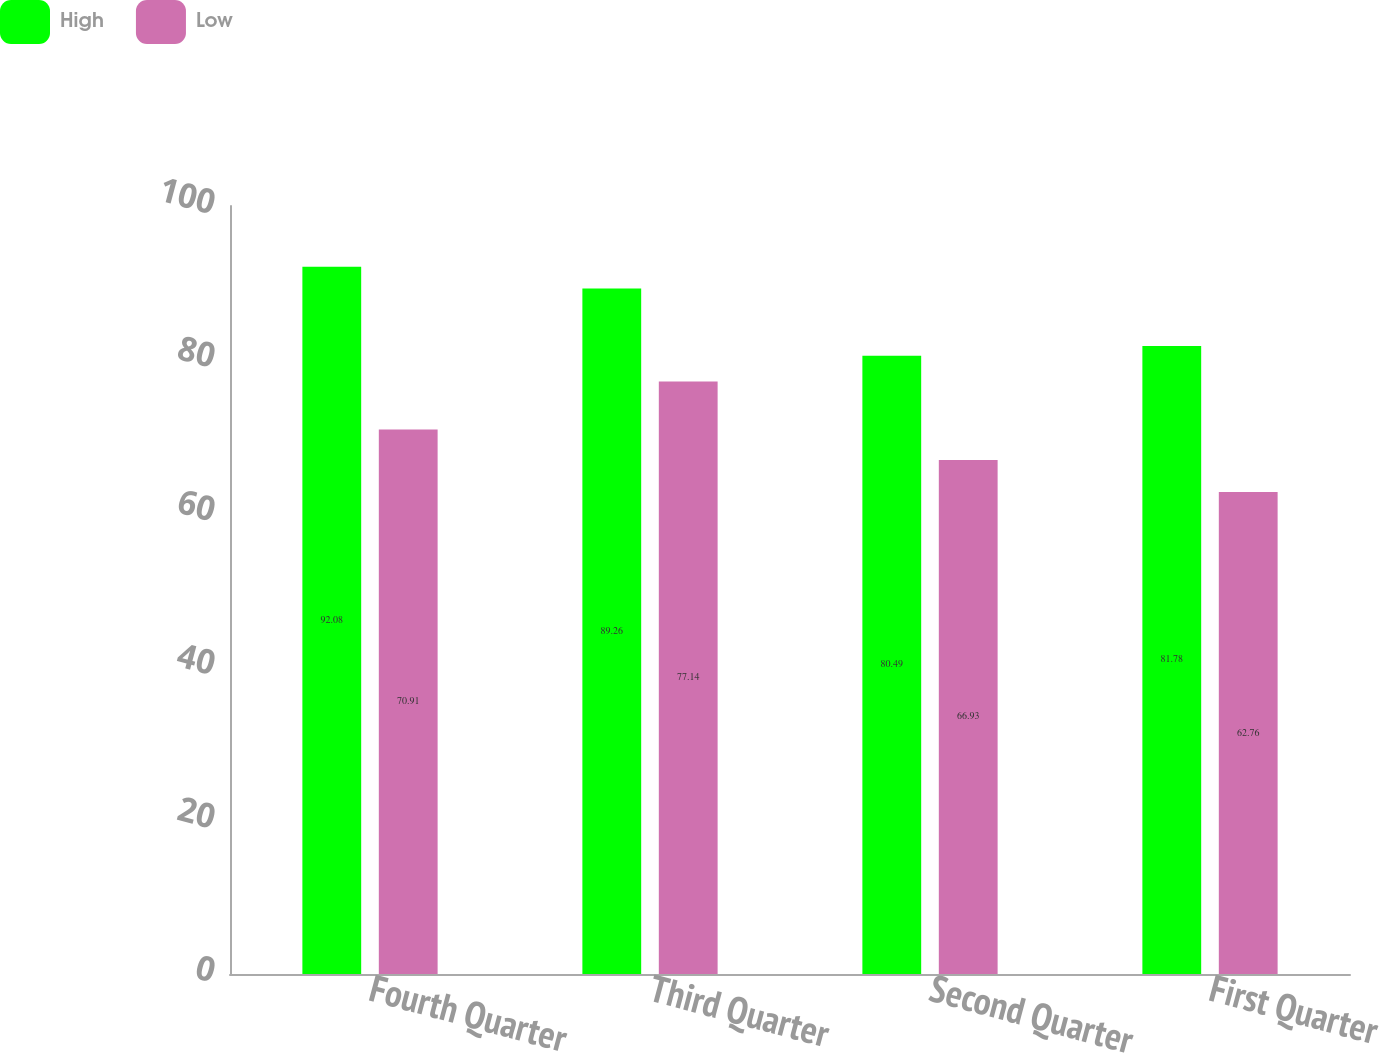Convert chart. <chart><loc_0><loc_0><loc_500><loc_500><stacked_bar_chart><ecel><fcel>Fourth Quarter<fcel>Third Quarter<fcel>Second Quarter<fcel>First Quarter<nl><fcel>High<fcel>92.08<fcel>89.26<fcel>80.49<fcel>81.78<nl><fcel>Low<fcel>70.91<fcel>77.14<fcel>66.93<fcel>62.76<nl></chart> 